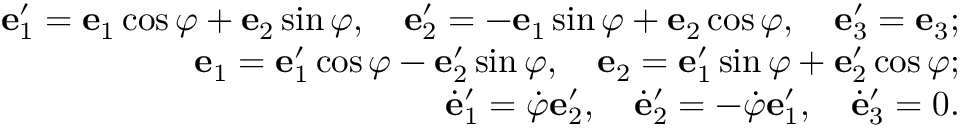<formula> <loc_0><loc_0><loc_500><loc_500>\begin{array} { r } { { e } _ { 1 } ^ { \prime } = { e } _ { 1 } \cos \varphi + { e } _ { 2 } \sin \varphi , \quad e _ { 2 } ^ { \prime } = - { e } _ { 1 } \sin \varphi + { e } _ { 2 } \cos \varphi , \quad e _ { 3 } ^ { \prime } = { e } _ { 3 } ; } \\ { { e } _ { 1 } = { e } _ { 1 } ^ { \prime } \cos \varphi - { e } _ { 2 } ^ { \prime } \sin \varphi , \quad e _ { 2 } = { e } _ { 1 } ^ { \prime } \sin \varphi + { e } _ { 2 } ^ { \prime } \cos \varphi ; } \\ { \dot { e } _ { 1 } ^ { \prime } = \dot { \varphi } { e } _ { 2 } ^ { \prime } , \quad \dot { e } _ { 2 } ^ { \prime } = - \dot { \varphi } { e } _ { 1 } ^ { \prime } , \quad \dot { e } _ { 3 } ^ { \prime } = 0 . } \end{array}</formula> 